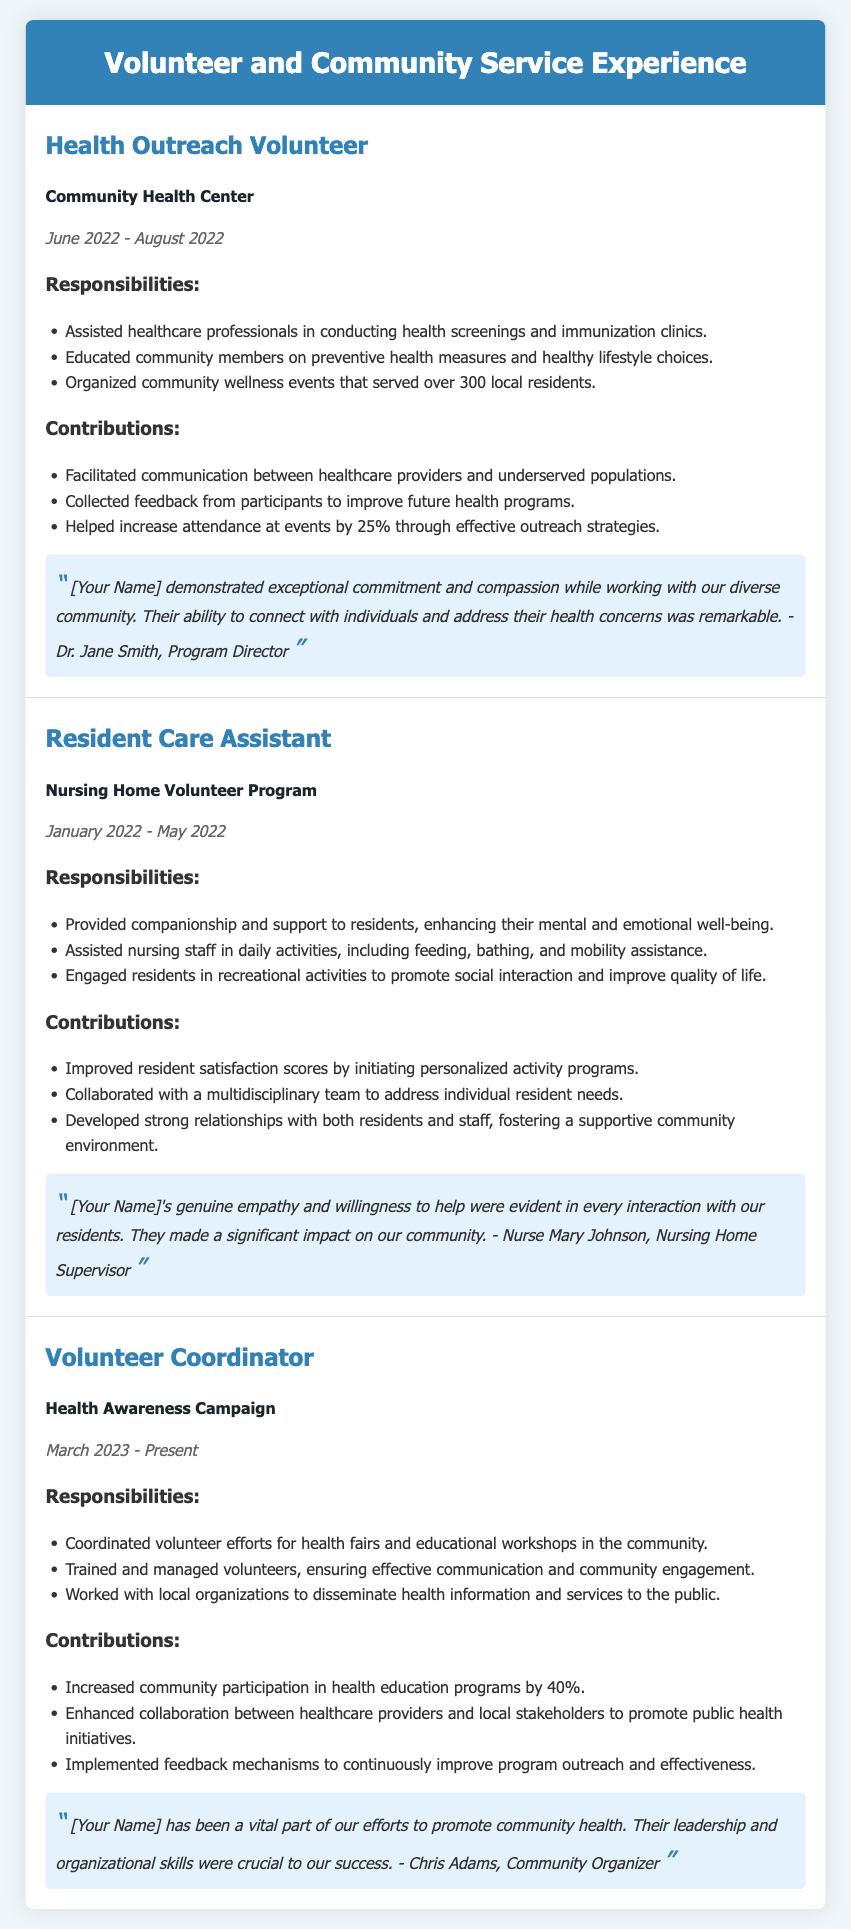what is the title of the document? The title of the document indicates the content covered, which is volunteer and community service experience.
Answer: Volunteer and Community Service Experience how many volunteer experiences are listed? The document contains three distinct volunteer experiences detailed in separate sections.
Answer: Three what organization did the Health Outreach Volunteer work for? The specific community organization where the volunteer experience took place is mentioned in the document.
Answer: Community Health Center during what month and year did the Resident Care Assistant role take place? The duration for this volunteer position is provided as a range of months and years in the document.
Answer: January 2022 - May 2022 what was the role of [Your Name] in the Health Awareness Campaign? The document explicitly states the responsibilities of the individual within the health campaign program.
Answer: Volunteer Coordinator which testimonial highlights the individual's impact on community health initiatives? Each experience includes a testimonial that provides insight into the individual’s contribution and effectiveness in their volunteer roles.
Answer: "[Your Name] has been a vital part of our efforts to promote community health." what percentage increase in community participation was achieved by the Volunteer Coordinator? The document specifies the percentage increase related to volunteer engagement in health education programs.
Answer: 40% what was one responsibility of the Health Outreach Volunteer? The document lists several responsibilities, indicating what the individual was tasked with in this role.
Answer: Assisted healthcare professionals in conducting health screenings and immunization clinics 